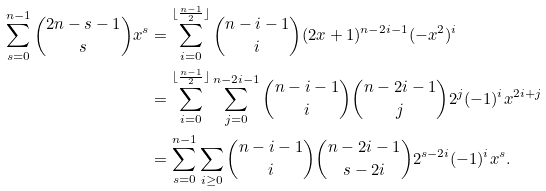<formula> <loc_0><loc_0><loc_500><loc_500>\sum _ { s = 0 } ^ { n - 1 } \binom { 2 n - s - 1 } { s } x ^ { s } & = \sum _ { i = 0 } ^ { \lfloor \frac { n - 1 } { 2 } \rfloor } \binom { n - i - 1 } { i } ( 2 x + 1 ) ^ { n - 2 i - 1 } ( - x ^ { 2 } ) ^ { i } \\ & = \sum _ { i = 0 } ^ { \lfloor \frac { n - 1 } { 2 } \rfloor } \sum _ { j = 0 } ^ { n - 2 i - 1 } \binom { n - i - 1 } { i } \binom { n - 2 i - 1 } { j } 2 ^ { j } ( - 1 ) ^ { i } x ^ { 2 i + j } \\ & = \sum _ { s = 0 } ^ { n - 1 } \sum _ { i \geq 0 } \binom { n - i - 1 } { i } \binom { n - 2 i - 1 } { s - 2 i } 2 ^ { s - 2 i } ( - 1 ) ^ { i } x ^ { s } .</formula> 